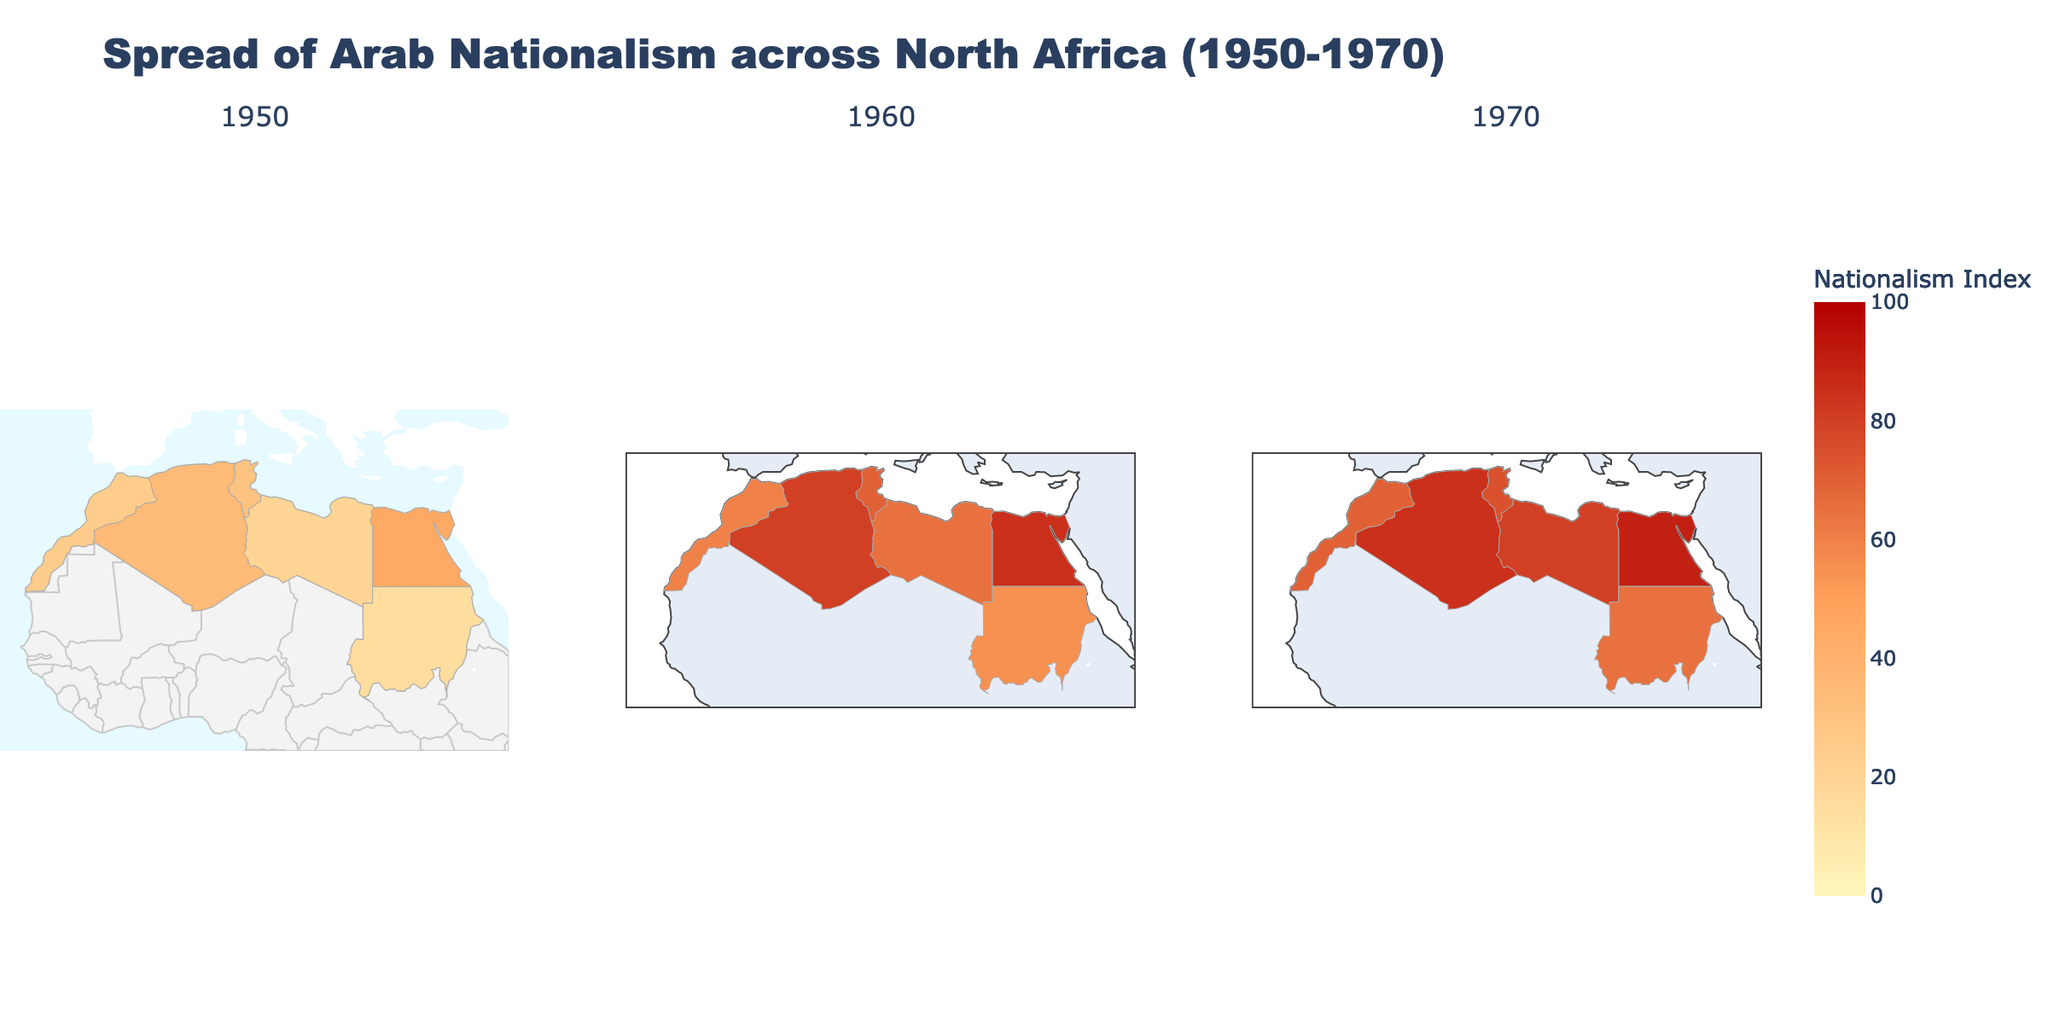What is the title of the figure? The title is usually prominently displayed at the top of a figure and summarizes what the figure represents. Here, the title can be seen at the top center of the figure.
Answer: Spread of Arab Nationalism across North Africa (1950-1970) Which country had the highest Nationalism Index in 1970? To find the country with the highest Nationalism Index, look at the values within the 1970 subplot and identify the maximum value and the corresponding country.
Answer: Egypt What colors are used to indicate high levels of Nationalism Index? Visual elements like color scales help convey the range of data. In the figure, the colors toward the darker red end indicate higher values.
Answer: Dark red How much did the Nationalism Index in Libya increase from 1950 to 1960? To find the increase, subtract the 1950 value for Libya (20) from the 1960 value (65).
Answer: 45 Did any country's Nationalism Index decrease from 1960 to 1970? Check the values for each country between 1960 and 1970 to see if any value decreases. Every value increased or remained the same.
Answer: No Between Algeria and Morocco, which country had a greater increase in the Nationalism Index from 1950 to 1970? Calculate the increase for Algeria (85-35=50) and Morocco (70-25=45), then compare the two.
Answer: Algeria Which year shows the most variation in colors across the countries? Look at the subplots for each year and observe the range of colors used, indicating different Nationalism Index values.
Answer: 1950 If you average the Nationalism Index of all countries in 1960, what would it be? Sum the Nationalism Index values for 1960 and divide by the number of countries: (85+65+70+80+60+55)/6 = 69.1667.
Answer: 69.17 Which region had the lowest Nationalism Index in 1950, and what was the value? Look at the 1950 subplot and identify the country with the lowest Nationalism Index value.
Answer: Sudan (15) What is the median Nationalism Index for the year 1970 across all countries? Arrange the 1970 values in ascending order (65, 70, 75, 80, 85, 90) and find the middle number(s). The median is the average of the third and fourth values: (75+80)/2 = 77.5.
Answer: 77.5 